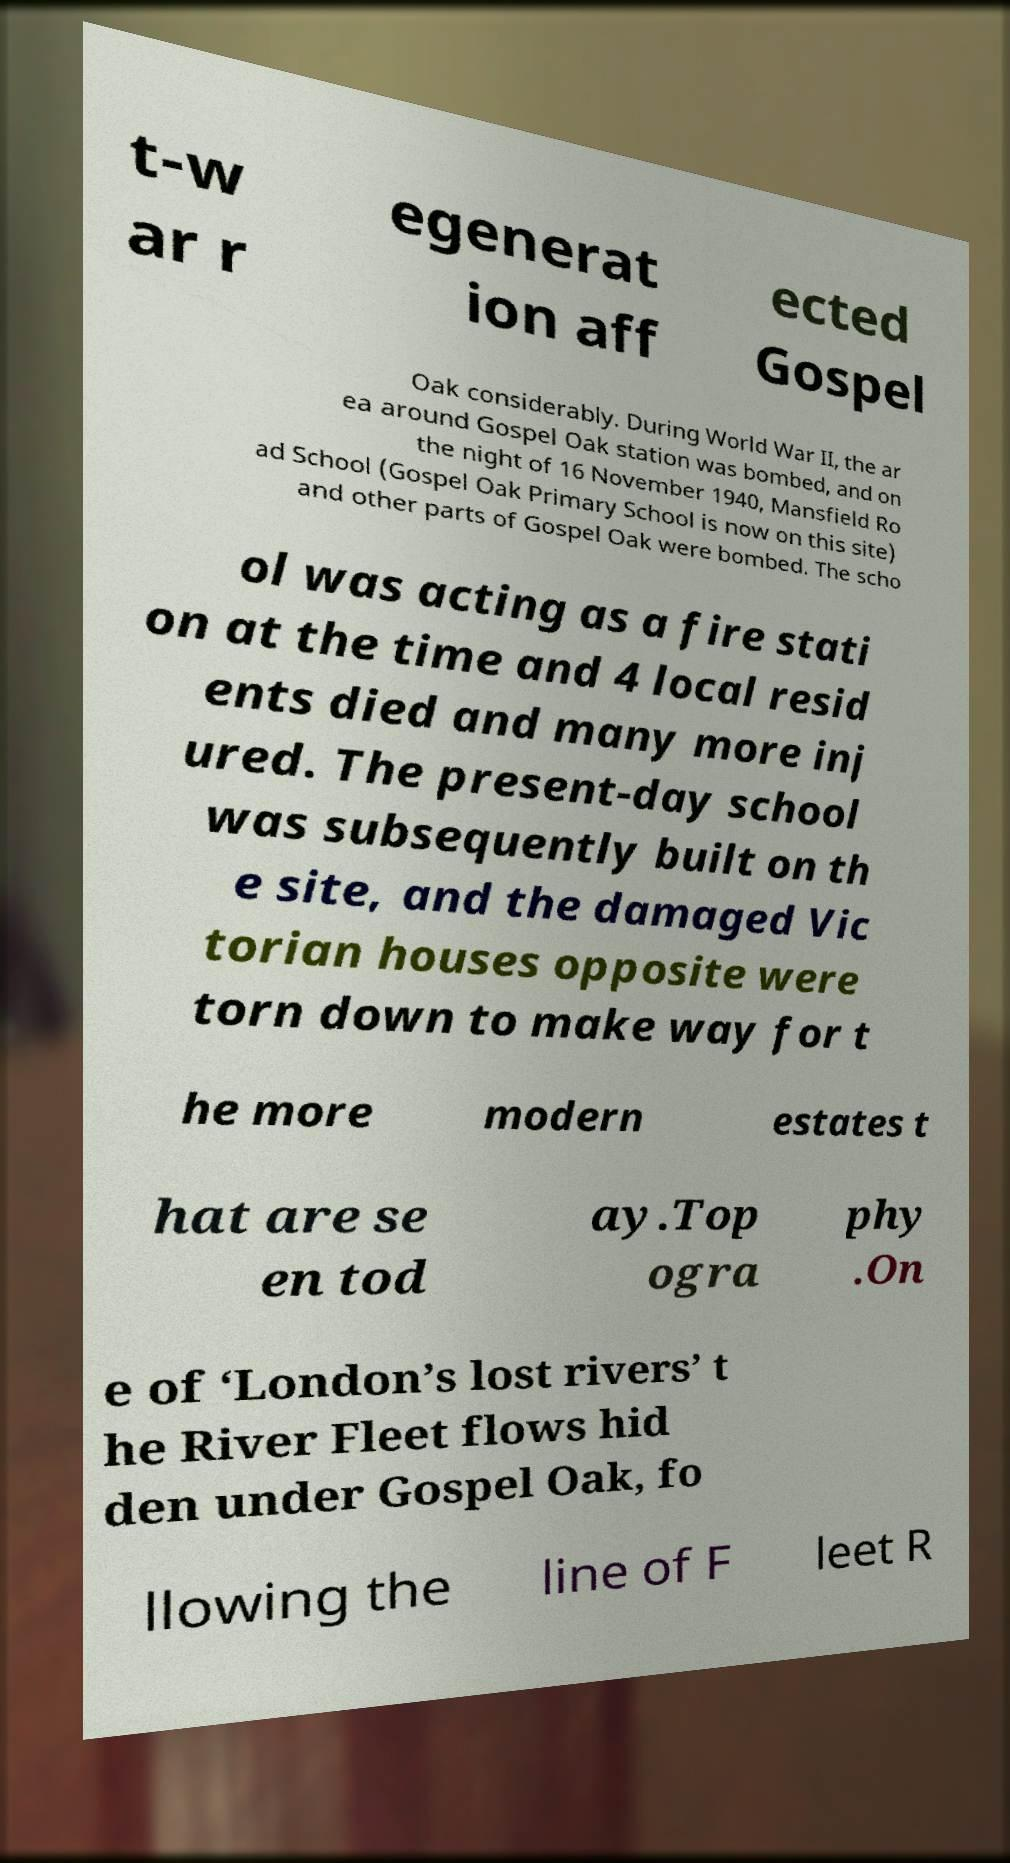Please identify and transcribe the text found in this image. t-w ar r egenerat ion aff ected Gospel Oak considerably. During World War II, the ar ea around Gospel Oak station was bombed, and on the night of 16 November 1940, Mansfield Ro ad School (Gospel Oak Primary School is now on this site) and other parts of Gospel Oak were bombed. The scho ol was acting as a fire stati on at the time and 4 local resid ents died and many more inj ured. The present-day school was subsequently built on th e site, and the damaged Vic torian houses opposite were torn down to make way for t he more modern estates t hat are se en tod ay.Top ogra phy .On e of ‘London’s lost rivers’ t he River Fleet flows hid den under Gospel Oak, fo llowing the line of F leet R 